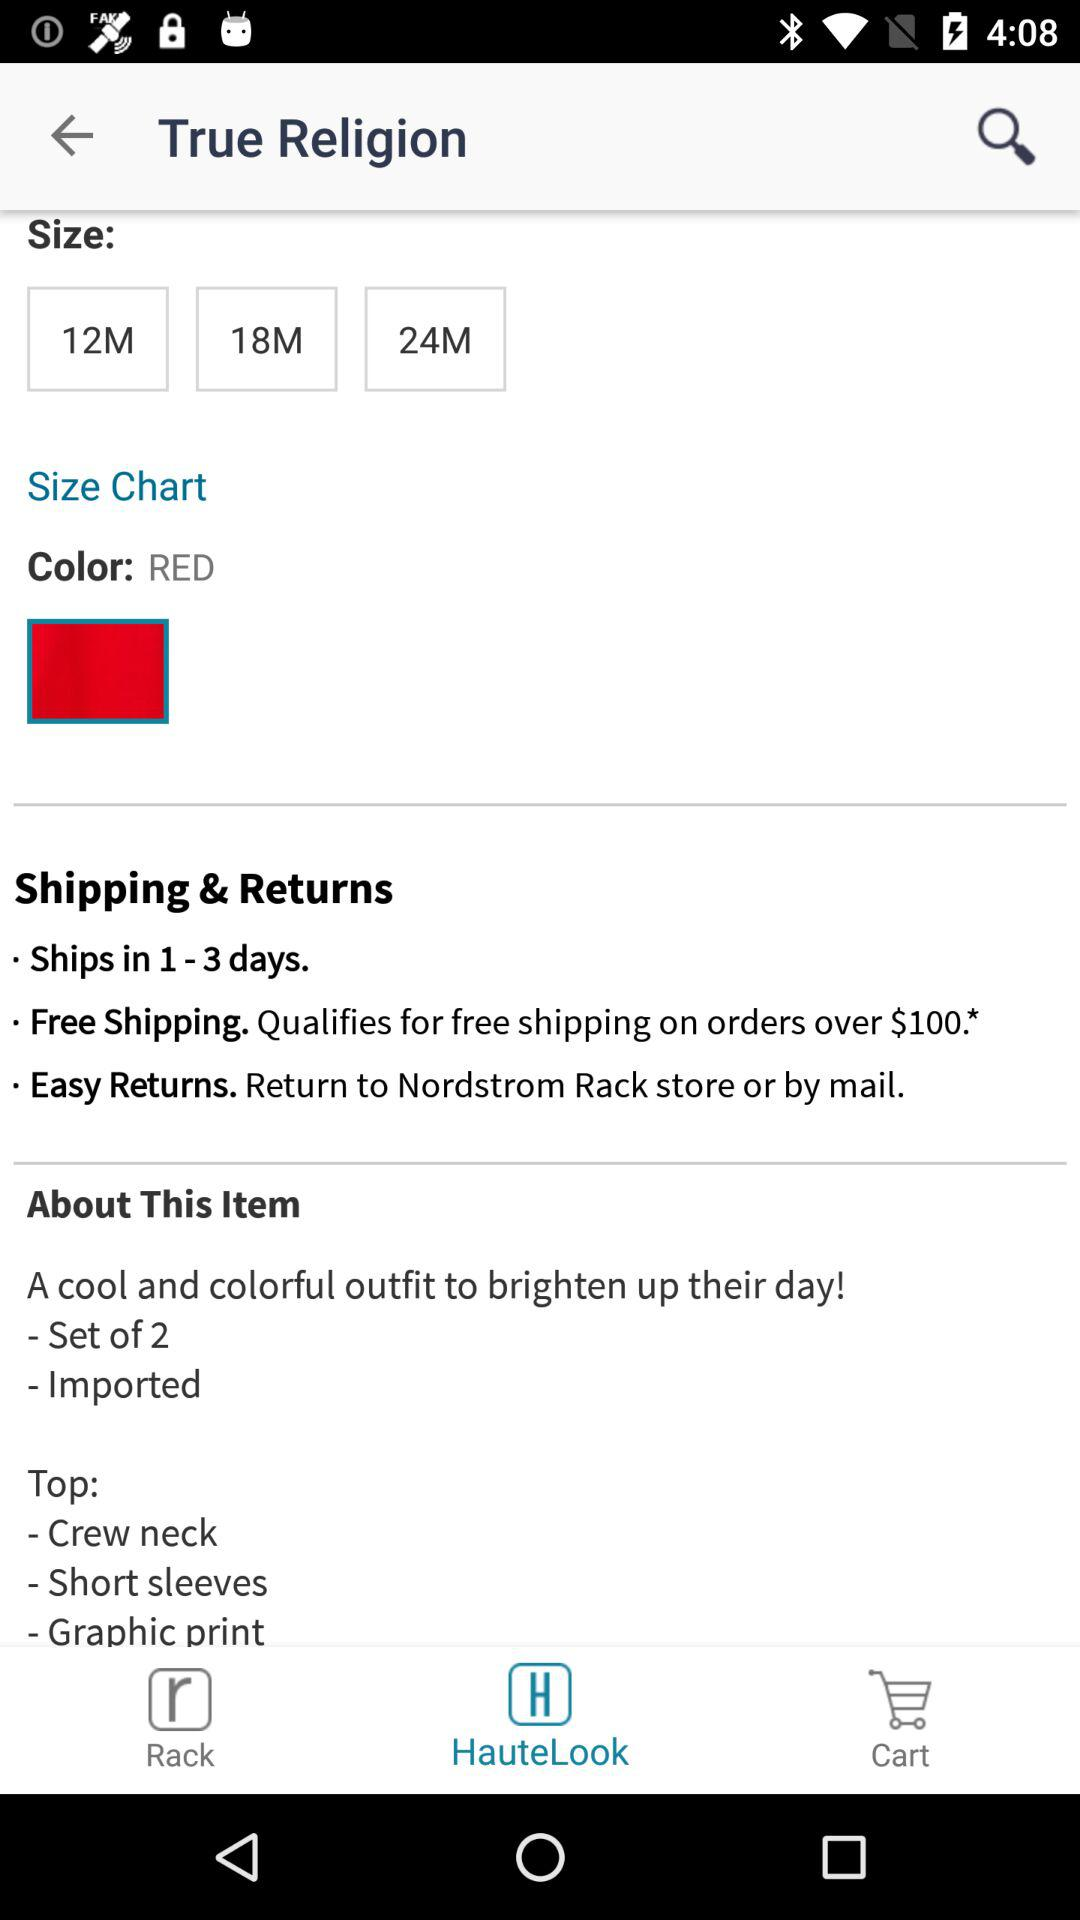How many sizes are available for this item?
Answer the question using a single word or phrase. 3 